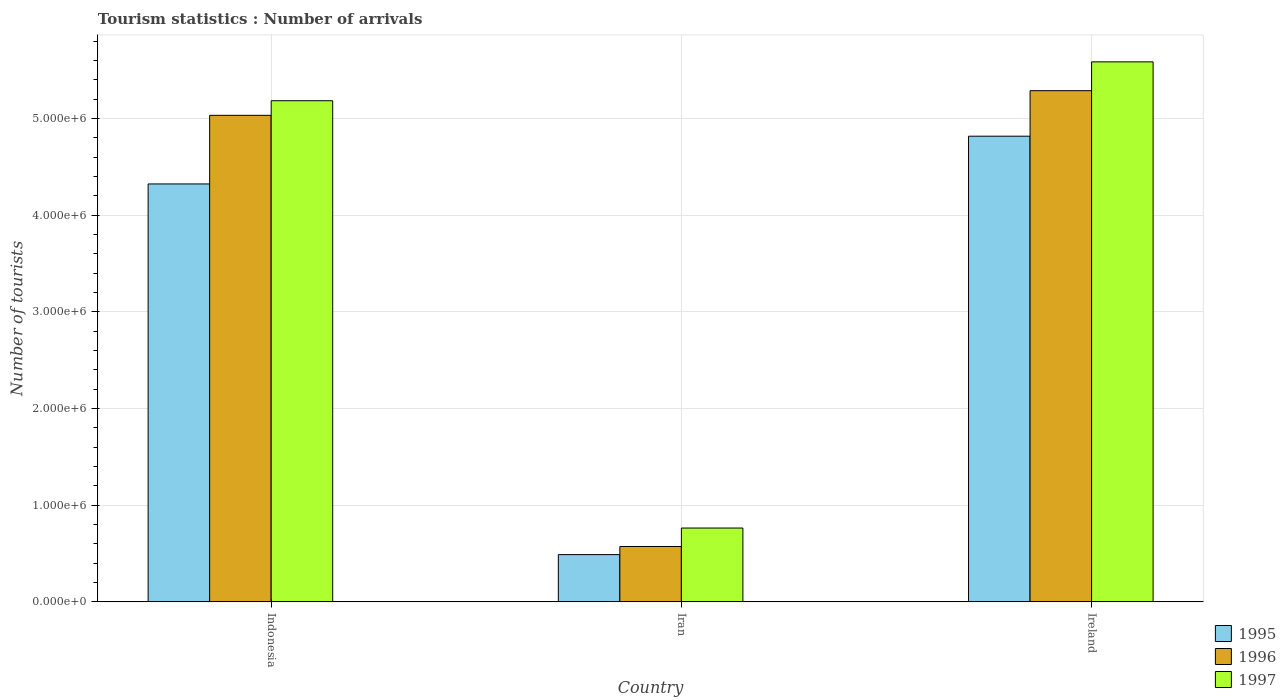How many groups of bars are there?
Your answer should be very brief. 3. Are the number of bars on each tick of the X-axis equal?
Your answer should be very brief. Yes. How many bars are there on the 1st tick from the left?
Offer a terse response. 3. What is the label of the 2nd group of bars from the left?
Offer a very short reply. Iran. What is the number of tourist arrivals in 1996 in Indonesia?
Provide a succinct answer. 5.03e+06. Across all countries, what is the maximum number of tourist arrivals in 1996?
Offer a terse response. 5.29e+06. Across all countries, what is the minimum number of tourist arrivals in 1996?
Keep it short and to the point. 5.73e+05. In which country was the number of tourist arrivals in 1997 maximum?
Keep it short and to the point. Ireland. In which country was the number of tourist arrivals in 1995 minimum?
Your response must be concise. Iran. What is the total number of tourist arrivals in 1996 in the graph?
Ensure brevity in your answer.  1.09e+07. What is the difference between the number of tourist arrivals in 1996 in Indonesia and that in Iran?
Offer a terse response. 4.46e+06. What is the difference between the number of tourist arrivals in 1997 in Ireland and the number of tourist arrivals in 1995 in Iran?
Your answer should be very brief. 5.10e+06. What is the average number of tourist arrivals in 1997 per country?
Offer a very short reply. 3.85e+06. What is the difference between the number of tourist arrivals of/in 1996 and number of tourist arrivals of/in 1995 in Iran?
Provide a short and direct response. 8.40e+04. In how many countries, is the number of tourist arrivals in 1995 greater than 3400000?
Your answer should be very brief. 2. What is the ratio of the number of tourist arrivals in 1996 in Iran to that in Ireland?
Provide a short and direct response. 0.11. Is the difference between the number of tourist arrivals in 1996 in Iran and Ireland greater than the difference between the number of tourist arrivals in 1995 in Iran and Ireland?
Make the answer very short. No. What is the difference between the highest and the second highest number of tourist arrivals in 1997?
Keep it short and to the point. 4.82e+06. What is the difference between the highest and the lowest number of tourist arrivals in 1995?
Offer a very short reply. 4.33e+06. In how many countries, is the number of tourist arrivals in 1996 greater than the average number of tourist arrivals in 1996 taken over all countries?
Provide a succinct answer. 2. What does the 3rd bar from the right in Ireland represents?
Ensure brevity in your answer.  1995. How many bars are there?
Provide a succinct answer. 9. Are all the bars in the graph horizontal?
Ensure brevity in your answer.  No. What is the difference between two consecutive major ticks on the Y-axis?
Make the answer very short. 1.00e+06. Does the graph contain any zero values?
Offer a terse response. No. How many legend labels are there?
Give a very brief answer. 3. What is the title of the graph?
Your response must be concise. Tourism statistics : Number of arrivals. What is the label or title of the Y-axis?
Provide a short and direct response. Number of tourists. What is the Number of tourists of 1995 in Indonesia?
Offer a very short reply. 4.32e+06. What is the Number of tourists of 1996 in Indonesia?
Your response must be concise. 5.03e+06. What is the Number of tourists in 1997 in Indonesia?
Keep it short and to the point. 5.18e+06. What is the Number of tourists of 1995 in Iran?
Provide a short and direct response. 4.89e+05. What is the Number of tourists of 1996 in Iran?
Make the answer very short. 5.73e+05. What is the Number of tourists in 1997 in Iran?
Provide a succinct answer. 7.64e+05. What is the Number of tourists of 1995 in Ireland?
Your answer should be compact. 4.82e+06. What is the Number of tourists of 1996 in Ireland?
Offer a terse response. 5.29e+06. What is the Number of tourists of 1997 in Ireland?
Keep it short and to the point. 5.59e+06. Across all countries, what is the maximum Number of tourists of 1995?
Make the answer very short. 4.82e+06. Across all countries, what is the maximum Number of tourists of 1996?
Provide a short and direct response. 5.29e+06. Across all countries, what is the maximum Number of tourists in 1997?
Your answer should be very brief. 5.59e+06. Across all countries, what is the minimum Number of tourists in 1995?
Offer a terse response. 4.89e+05. Across all countries, what is the minimum Number of tourists of 1996?
Offer a terse response. 5.73e+05. Across all countries, what is the minimum Number of tourists of 1997?
Give a very brief answer. 7.64e+05. What is the total Number of tourists of 1995 in the graph?
Provide a short and direct response. 9.63e+06. What is the total Number of tourists in 1996 in the graph?
Make the answer very short. 1.09e+07. What is the total Number of tourists in 1997 in the graph?
Provide a succinct answer. 1.15e+07. What is the difference between the Number of tourists in 1995 in Indonesia and that in Iran?
Your response must be concise. 3.84e+06. What is the difference between the Number of tourists in 1996 in Indonesia and that in Iran?
Provide a short and direct response. 4.46e+06. What is the difference between the Number of tourists of 1997 in Indonesia and that in Iran?
Ensure brevity in your answer.  4.42e+06. What is the difference between the Number of tourists in 1995 in Indonesia and that in Ireland?
Your answer should be compact. -4.94e+05. What is the difference between the Number of tourists in 1996 in Indonesia and that in Ireland?
Your answer should be compact. -2.55e+05. What is the difference between the Number of tourists in 1997 in Indonesia and that in Ireland?
Offer a very short reply. -4.02e+05. What is the difference between the Number of tourists in 1995 in Iran and that in Ireland?
Offer a very short reply. -4.33e+06. What is the difference between the Number of tourists of 1996 in Iran and that in Ireland?
Offer a terse response. -4.72e+06. What is the difference between the Number of tourists of 1997 in Iran and that in Ireland?
Make the answer very short. -4.82e+06. What is the difference between the Number of tourists of 1995 in Indonesia and the Number of tourists of 1996 in Iran?
Your response must be concise. 3.75e+06. What is the difference between the Number of tourists of 1995 in Indonesia and the Number of tourists of 1997 in Iran?
Offer a terse response. 3.56e+06. What is the difference between the Number of tourists in 1996 in Indonesia and the Number of tourists in 1997 in Iran?
Ensure brevity in your answer.  4.27e+06. What is the difference between the Number of tourists of 1995 in Indonesia and the Number of tourists of 1996 in Ireland?
Offer a very short reply. -9.65e+05. What is the difference between the Number of tourists in 1995 in Indonesia and the Number of tourists in 1997 in Ireland?
Provide a short and direct response. -1.26e+06. What is the difference between the Number of tourists of 1996 in Indonesia and the Number of tourists of 1997 in Ireland?
Offer a very short reply. -5.53e+05. What is the difference between the Number of tourists in 1995 in Iran and the Number of tourists in 1996 in Ireland?
Your answer should be compact. -4.80e+06. What is the difference between the Number of tourists in 1995 in Iran and the Number of tourists in 1997 in Ireland?
Your answer should be compact. -5.10e+06. What is the difference between the Number of tourists of 1996 in Iran and the Number of tourists of 1997 in Ireland?
Ensure brevity in your answer.  -5.01e+06. What is the average Number of tourists of 1995 per country?
Make the answer very short. 3.21e+06. What is the average Number of tourists of 1996 per country?
Your response must be concise. 3.63e+06. What is the average Number of tourists of 1997 per country?
Your answer should be compact. 3.85e+06. What is the difference between the Number of tourists in 1995 and Number of tourists in 1996 in Indonesia?
Keep it short and to the point. -7.10e+05. What is the difference between the Number of tourists of 1995 and Number of tourists of 1997 in Indonesia?
Ensure brevity in your answer.  -8.61e+05. What is the difference between the Number of tourists of 1996 and Number of tourists of 1997 in Indonesia?
Your answer should be compact. -1.51e+05. What is the difference between the Number of tourists of 1995 and Number of tourists of 1996 in Iran?
Your answer should be very brief. -8.40e+04. What is the difference between the Number of tourists in 1995 and Number of tourists in 1997 in Iran?
Your answer should be compact. -2.75e+05. What is the difference between the Number of tourists in 1996 and Number of tourists in 1997 in Iran?
Offer a very short reply. -1.91e+05. What is the difference between the Number of tourists in 1995 and Number of tourists in 1996 in Ireland?
Offer a terse response. -4.71e+05. What is the difference between the Number of tourists of 1995 and Number of tourists of 1997 in Ireland?
Your response must be concise. -7.69e+05. What is the difference between the Number of tourists of 1996 and Number of tourists of 1997 in Ireland?
Provide a succinct answer. -2.98e+05. What is the ratio of the Number of tourists in 1995 in Indonesia to that in Iran?
Provide a succinct answer. 8.84. What is the ratio of the Number of tourists of 1996 in Indonesia to that in Iran?
Offer a very short reply. 8.79. What is the ratio of the Number of tourists of 1997 in Indonesia to that in Iran?
Provide a succinct answer. 6.79. What is the ratio of the Number of tourists of 1995 in Indonesia to that in Ireland?
Your answer should be compact. 0.9. What is the ratio of the Number of tourists in 1996 in Indonesia to that in Ireland?
Your answer should be compact. 0.95. What is the ratio of the Number of tourists of 1997 in Indonesia to that in Ireland?
Ensure brevity in your answer.  0.93. What is the ratio of the Number of tourists in 1995 in Iran to that in Ireland?
Provide a short and direct response. 0.1. What is the ratio of the Number of tourists of 1996 in Iran to that in Ireland?
Offer a very short reply. 0.11. What is the ratio of the Number of tourists in 1997 in Iran to that in Ireland?
Your response must be concise. 0.14. What is the difference between the highest and the second highest Number of tourists in 1995?
Give a very brief answer. 4.94e+05. What is the difference between the highest and the second highest Number of tourists in 1996?
Make the answer very short. 2.55e+05. What is the difference between the highest and the second highest Number of tourists of 1997?
Offer a terse response. 4.02e+05. What is the difference between the highest and the lowest Number of tourists in 1995?
Offer a very short reply. 4.33e+06. What is the difference between the highest and the lowest Number of tourists of 1996?
Keep it short and to the point. 4.72e+06. What is the difference between the highest and the lowest Number of tourists in 1997?
Provide a short and direct response. 4.82e+06. 